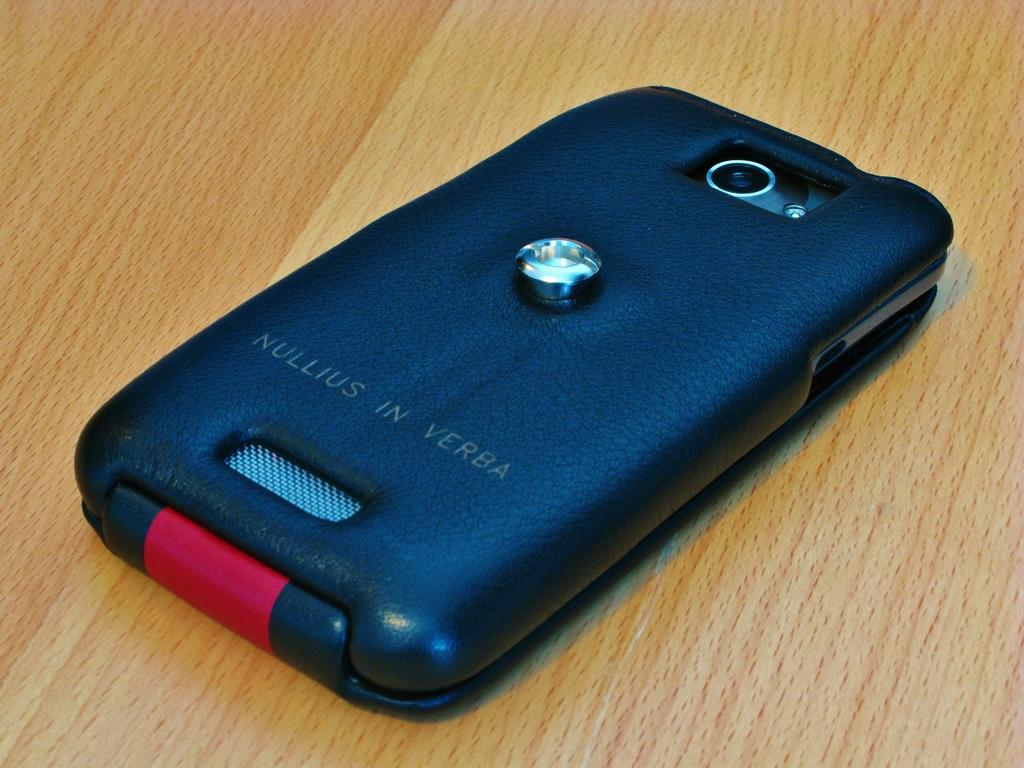<image>
Share a concise interpretation of the image provided. A smart phone is protected by a cover that has NULLIUS IN VERBA written on it. 